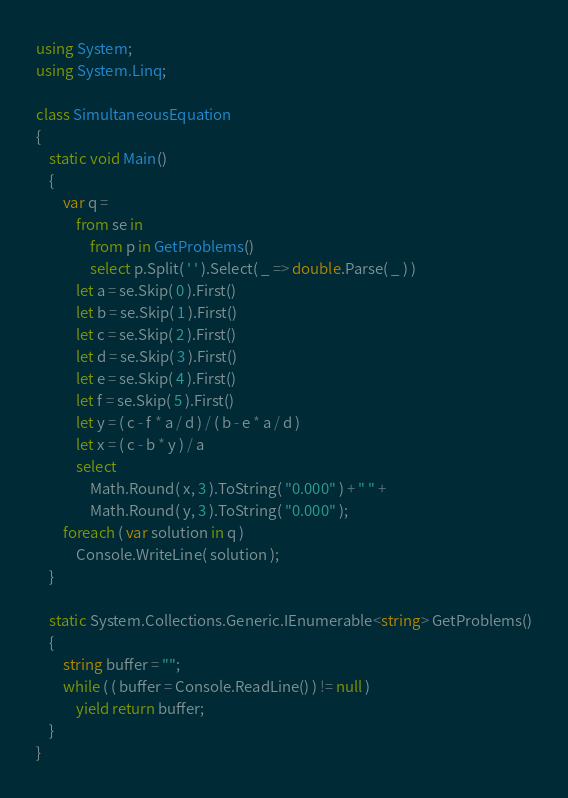<code> <loc_0><loc_0><loc_500><loc_500><_C#_>using System;
using System.Linq;

class SimultaneousEquation 
{
    static void Main()
    {
        var q =
            from se in 
                from p in GetProblems()
                select p.Split( ' ' ).Select( _ => double.Parse( _ ) )
            let a = se.Skip( 0 ).First()
            let b = se.Skip( 1 ).First()
            let c = se.Skip( 2 ).First()
            let d = se.Skip( 3 ).First()
            let e = se.Skip( 4 ).First()
            let f = se.Skip( 5 ).First()
            let y = ( c - f * a / d ) / ( b - e * a / d )
            let x = ( c - b * y ) / a
            select 
                Math.Round( x, 3 ).ToString( "0.000" ) + " " + 
                Math.Round( y, 3 ).ToString( "0.000" );
        foreach ( var solution in q )
            Console.WriteLine( solution );
    }

    static System.Collections.Generic.IEnumerable<string> GetProblems()
    {
        string buffer = "";
        while ( ( buffer = Console.ReadLine() ) != null )
            yield return buffer;
    }
}</code> 